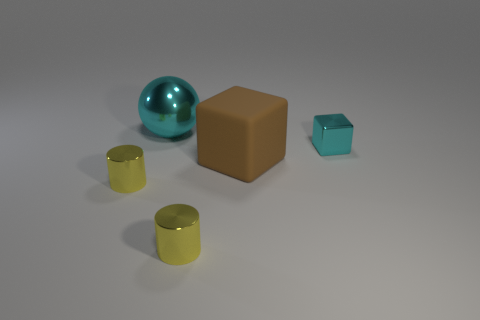Add 2 big cyan metal objects. How many objects exist? 7 Subtract all balls. How many objects are left? 4 Add 1 tiny gray metal objects. How many tiny gray metal objects exist? 1 Subtract 0 red cylinders. How many objects are left? 5 Subtract all large brown cubes. Subtract all big cyan metal objects. How many objects are left? 3 Add 1 cylinders. How many cylinders are left? 3 